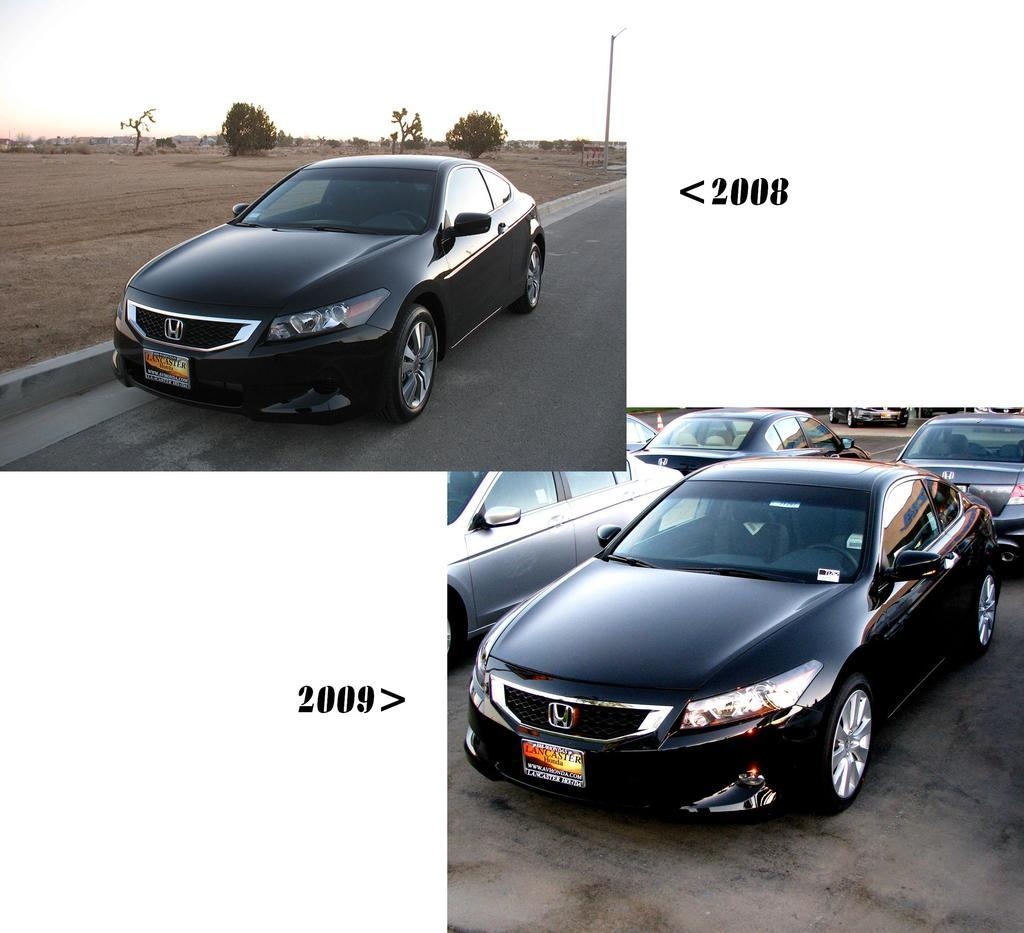What type of vehicles can be seen in the image? There are cars in the image. What other objects or elements are present in the image? There are trees and a rod visible in the image. What can be seen beneath the cars and trees? The ground is visible in the image. How many cows are grazing on the grass in the image? There are no cows present in the image; it features cars, trees, and a rod. What type of tax is being discussed in the image? There is no discussion of tax in the image; it focuses on cars, trees, and a rod. 